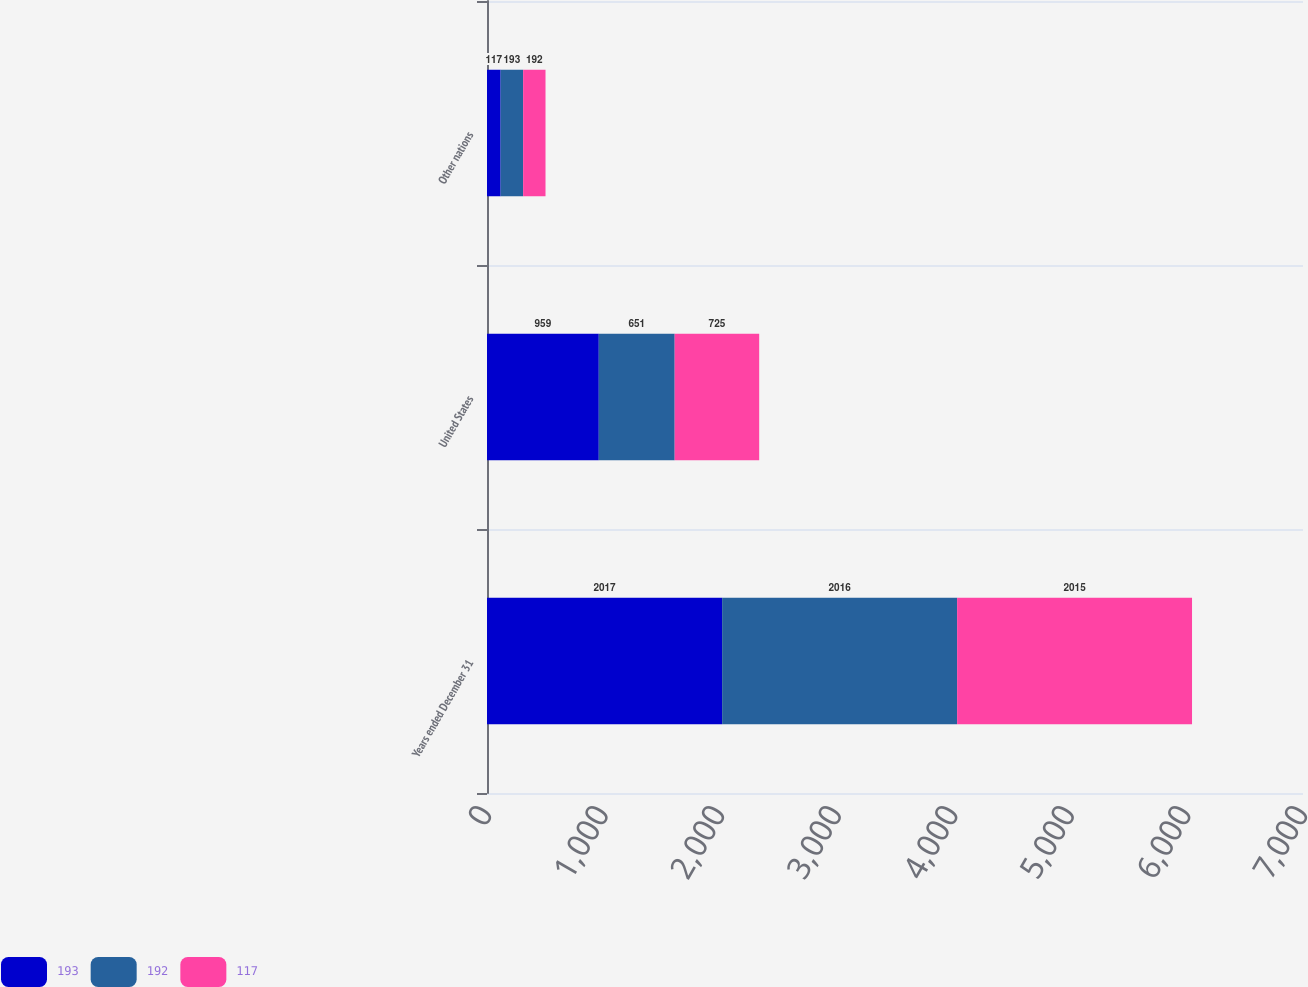Convert chart to OTSL. <chart><loc_0><loc_0><loc_500><loc_500><stacked_bar_chart><ecel><fcel>Years ended December 31<fcel>United States<fcel>Other nations<nl><fcel>193<fcel>2017<fcel>959<fcel>117<nl><fcel>192<fcel>2016<fcel>651<fcel>193<nl><fcel>117<fcel>2015<fcel>725<fcel>192<nl></chart> 